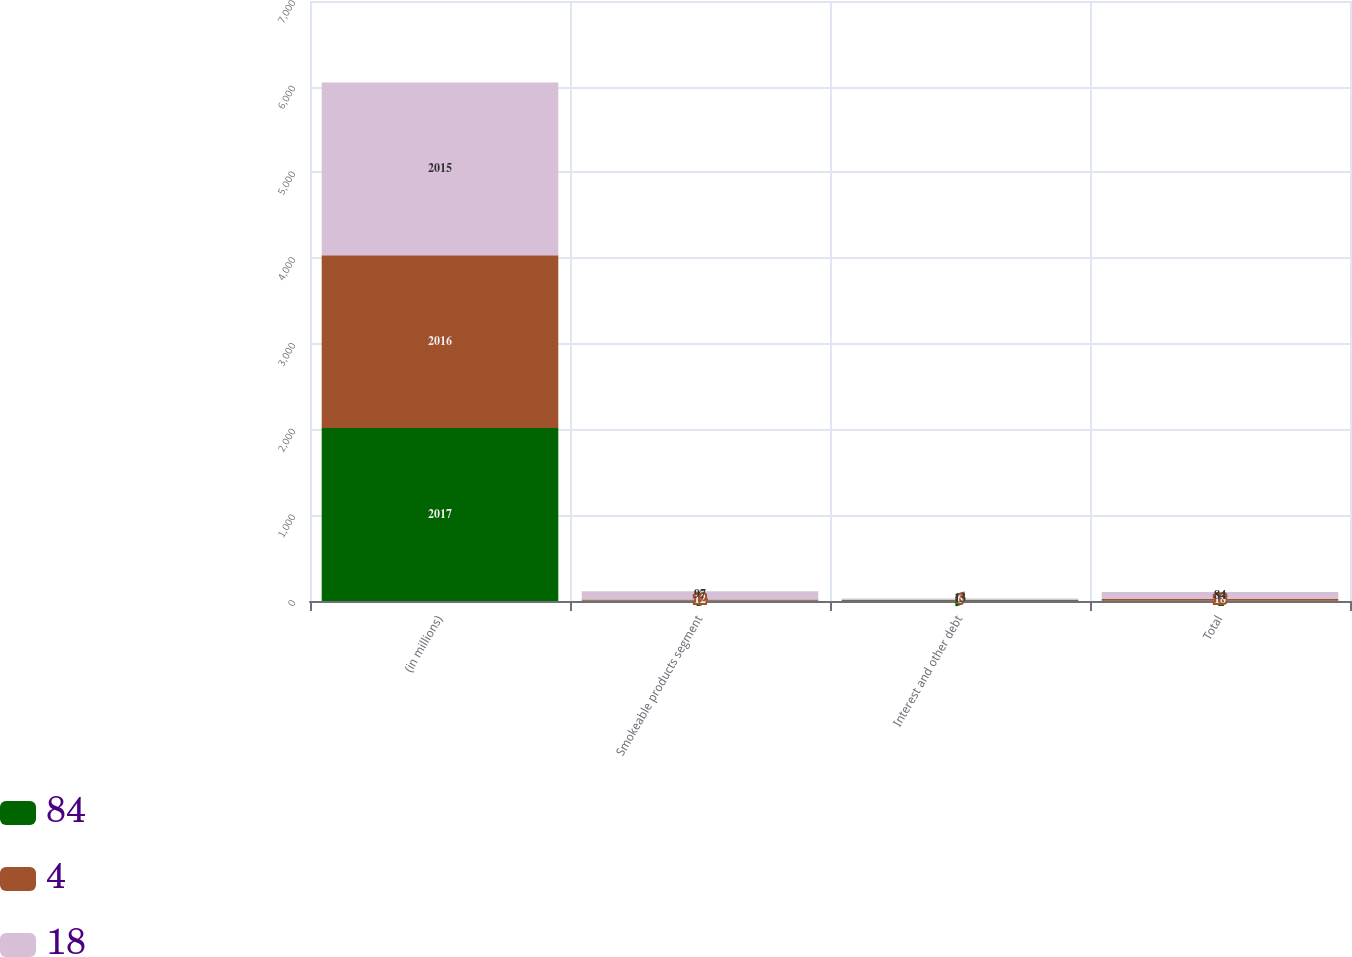Convert chart. <chart><loc_0><loc_0><loc_500><loc_500><stacked_bar_chart><ecel><fcel>(in millions)<fcel>Smokeable products segment<fcel>Interest and other debt<fcel>Total<nl><fcel>84<fcel>2017<fcel>5<fcel>9<fcel>4<nl><fcel>4<fcel>2016<fcel>12<fcel>6<fcel>18<nl><fcel>18<fcel>2015<fcel>97<fcel>13<fcel>84<nl></chart> 